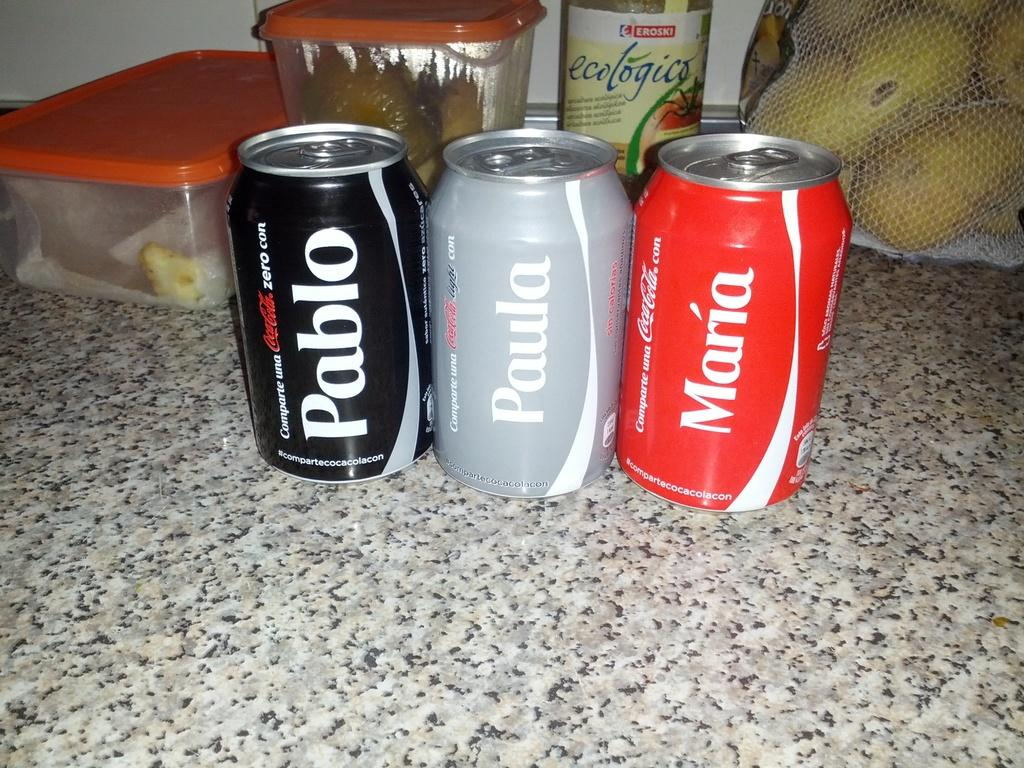<image>
Give a short and clear explanation of the subsequent image. the word Pablo that is on a can 